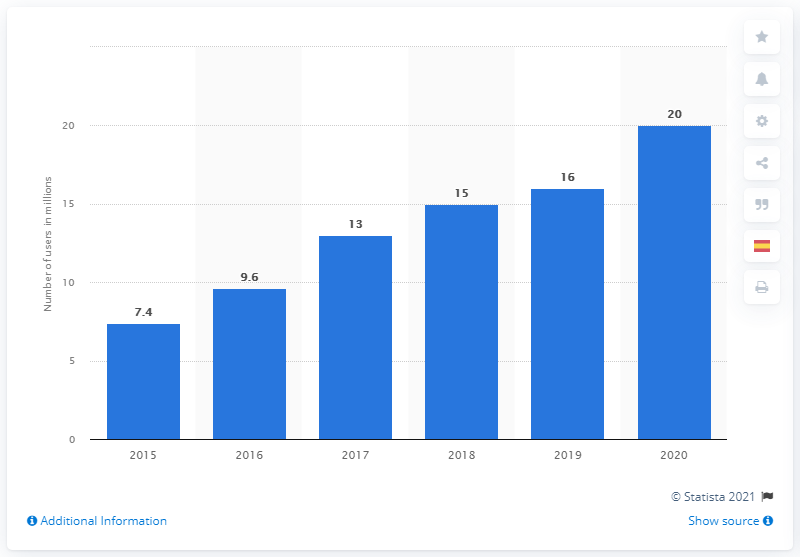Outline some significant characteristics in this image. In 2020, Instagram reached a total of 20 million accounts in Spain. 